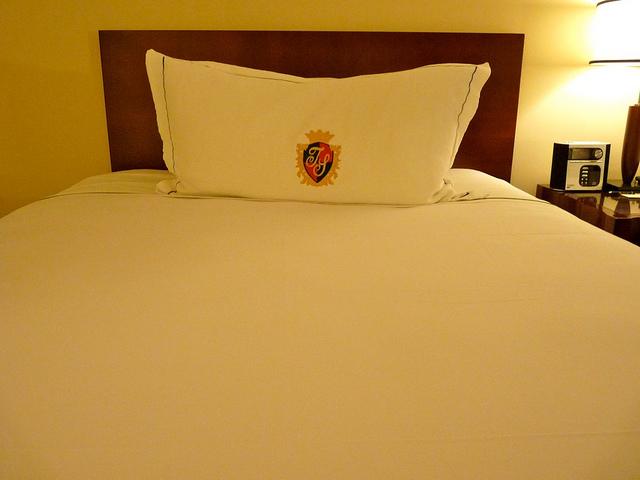Is the bedspread all one color?
Short answer required. Yes. Would a bed like this be rented for under $30?
Short answer required. No. Is the lamp on?
Quick response, please. Yes. What letters are on the pillow?
Quick response, please. Fs. 